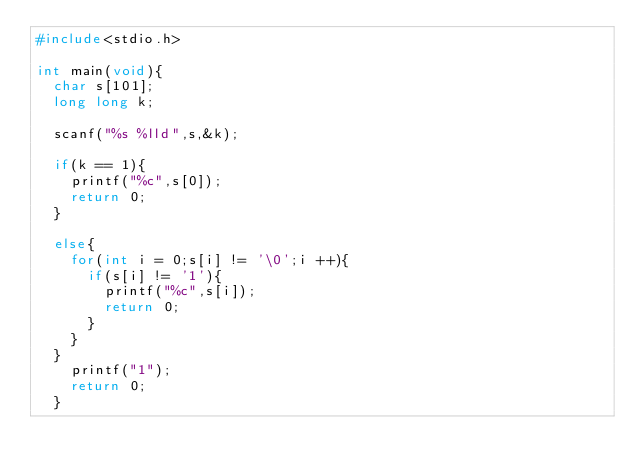<code> <loc_0><loc_0><loc_500><loc_500><_C_>#include<stdio.h>

int main(void){
  char s[101];
  long long k;
  
  scanf("%s %lld",s,&k);
  
  if(k == 1){
    printf("%c",s[0]);
    return 0;
  }
  
  else{
    for(int i = 0;s[i] != '\0';i ++){
      if(s[i] != '1'){
        printf("%c",s[i]);
        return 0;
      }
    }
  }
    printf("1");
    return 0;
  }
  </code> 